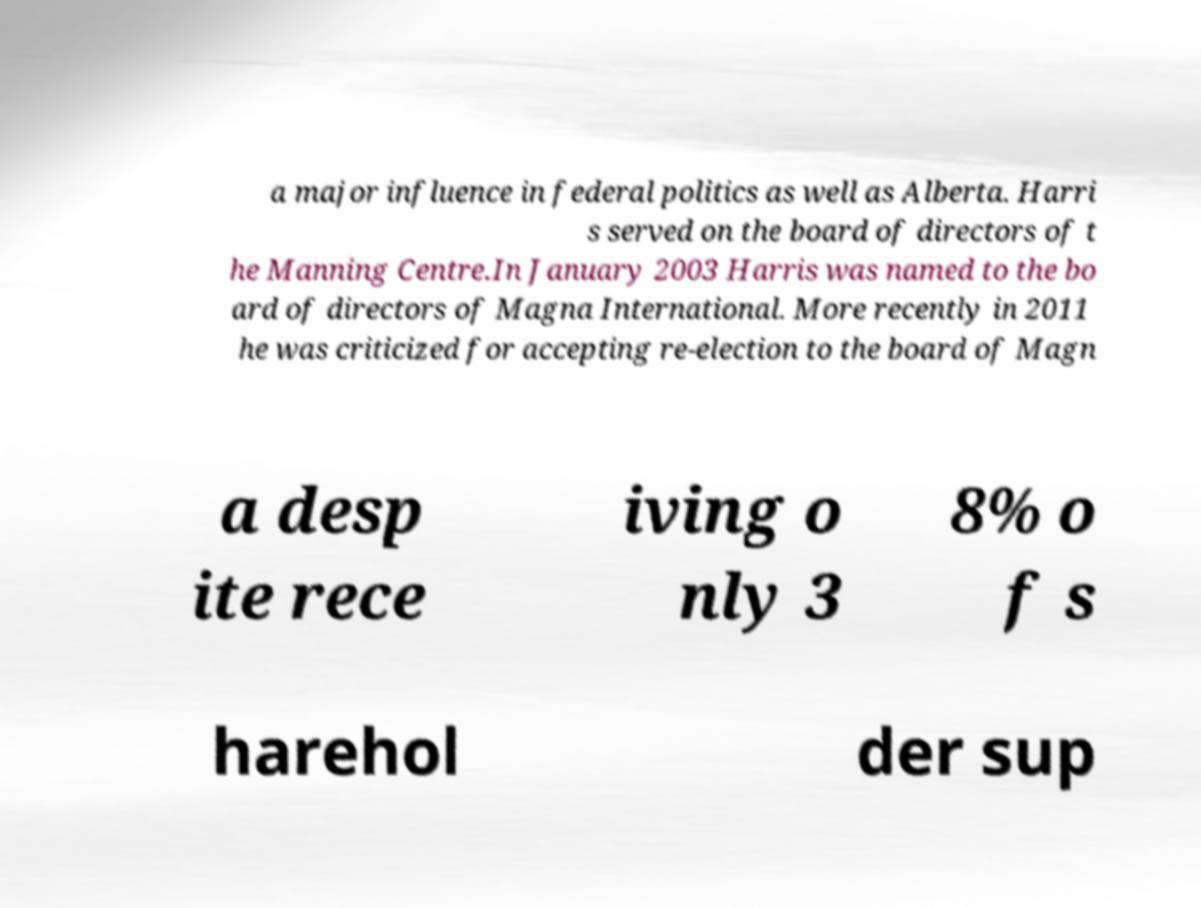What messages or text are displayed in this image? I need them in a readable, typed format. a major influence in federal politics as well as Alberta. Harri s served on the board of directors of t he Manning Centre.In January 2003 Harris was named to the bo ard of directors of Magna International. More recently in 2011 he was criticized for accepting re-election to the board of Magn a desp ite rece iving o nly 3 8% o f s harehol der sup 